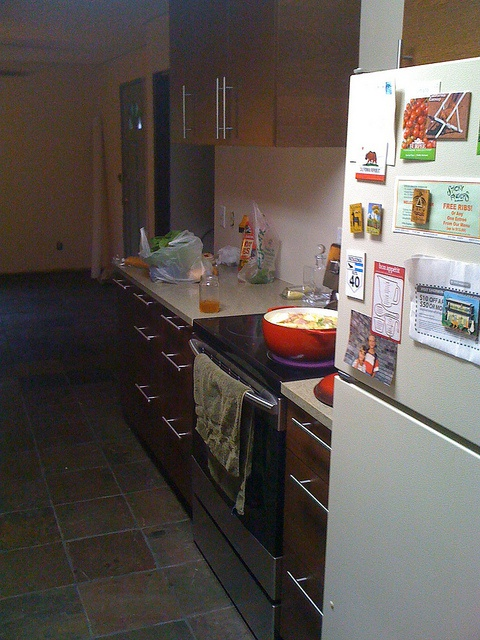Describe the objects in this image and their specific colors. I can see refrigerator in purple, darkgray, white, and gray tones, oven in purple, black, gray, and darkgreen tones, bowl in purple, brown, maroon, ivory, and khaki tones, bottle in purple, darkgray, and gray tones, and bottle in purple, gray, brown, and maroon tones in this image. 